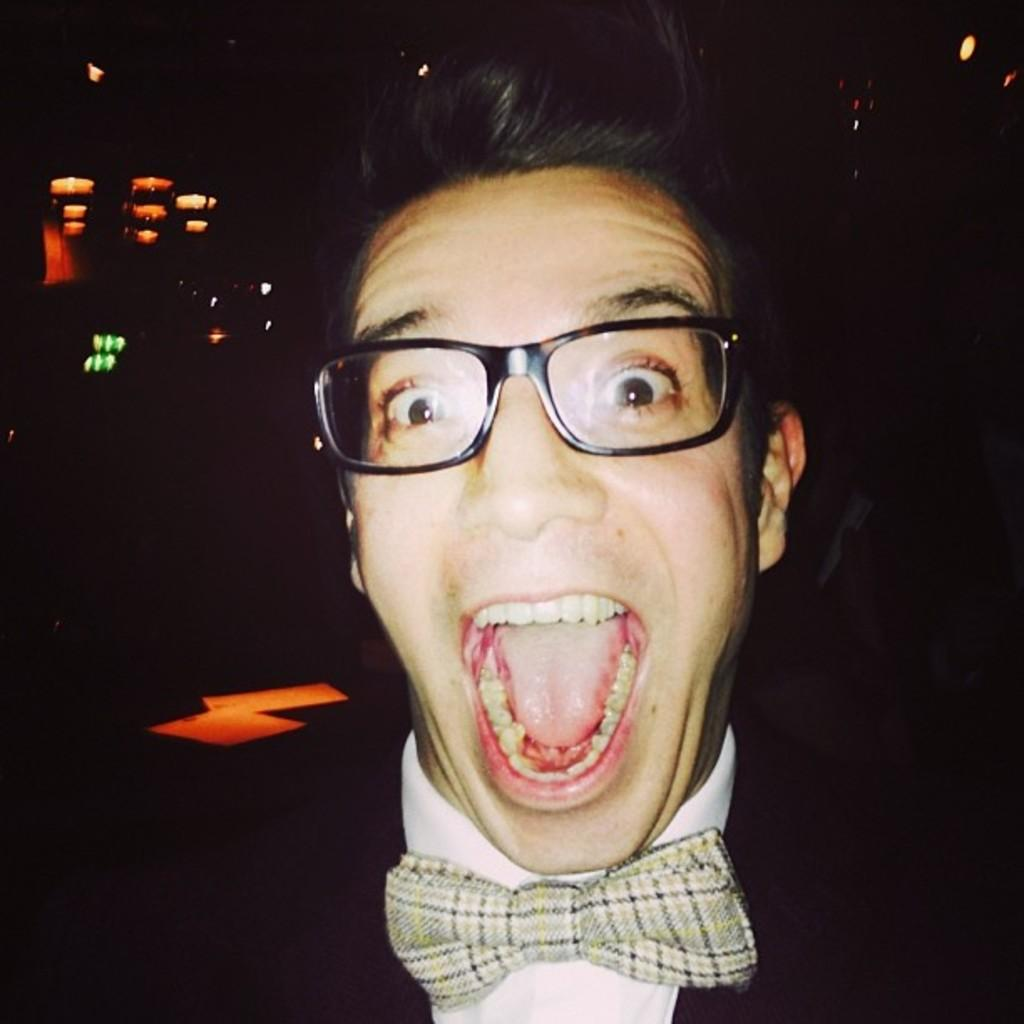What is the overall lighting condition of the image? The image is dark. Can you describe the person in the image? There is a person in the image, and they are wearing spectacles. What can be seen in the background of the image? There are lights visible in the background of the image. What is the person's tendency towards a specific flavor in the image? There is no information about the person's flavor preferences in the image. Can you describe the person's lips in the image? There is no information about the person's lips in the image. 